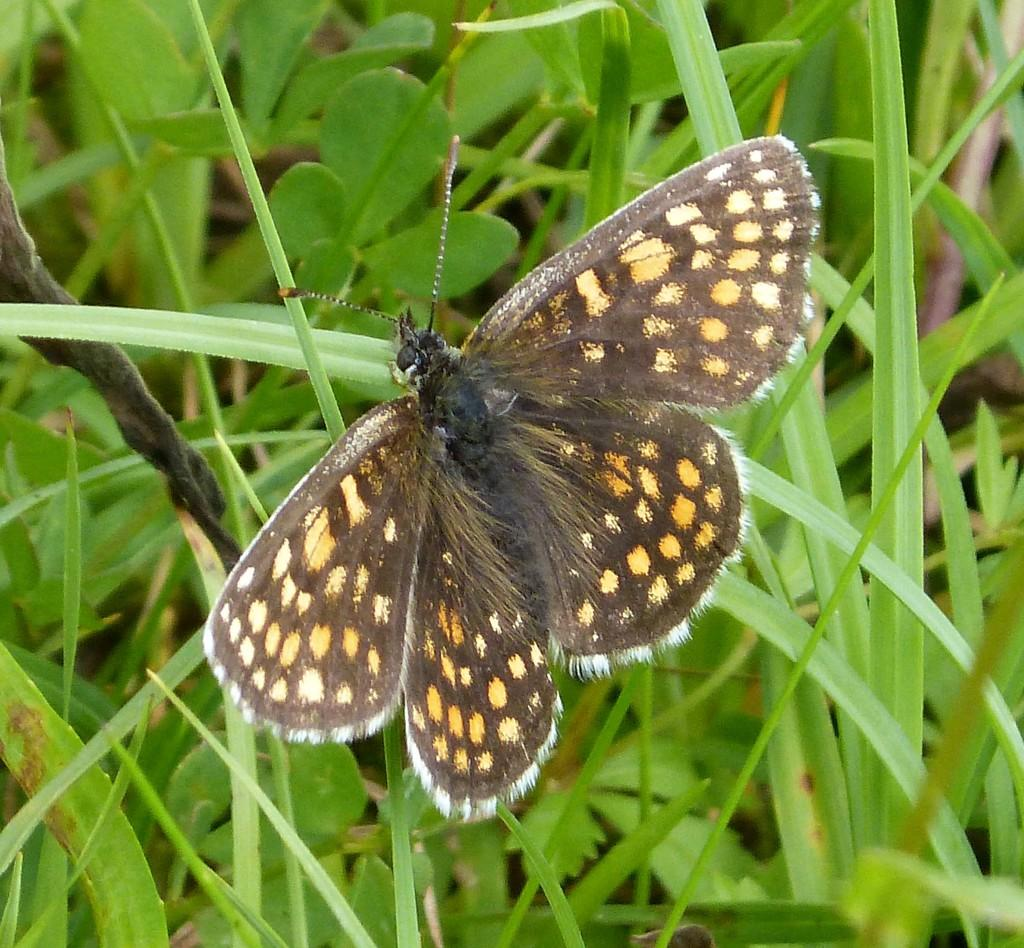What is the main subject of the image? There is a butterfly in the center of the image. What can be seen in the background of the image? There are leaves in the background of the image. Can you tell me how many times the person coughs in the image? There is no person present in the image, and therefore no coughing can be observed. 